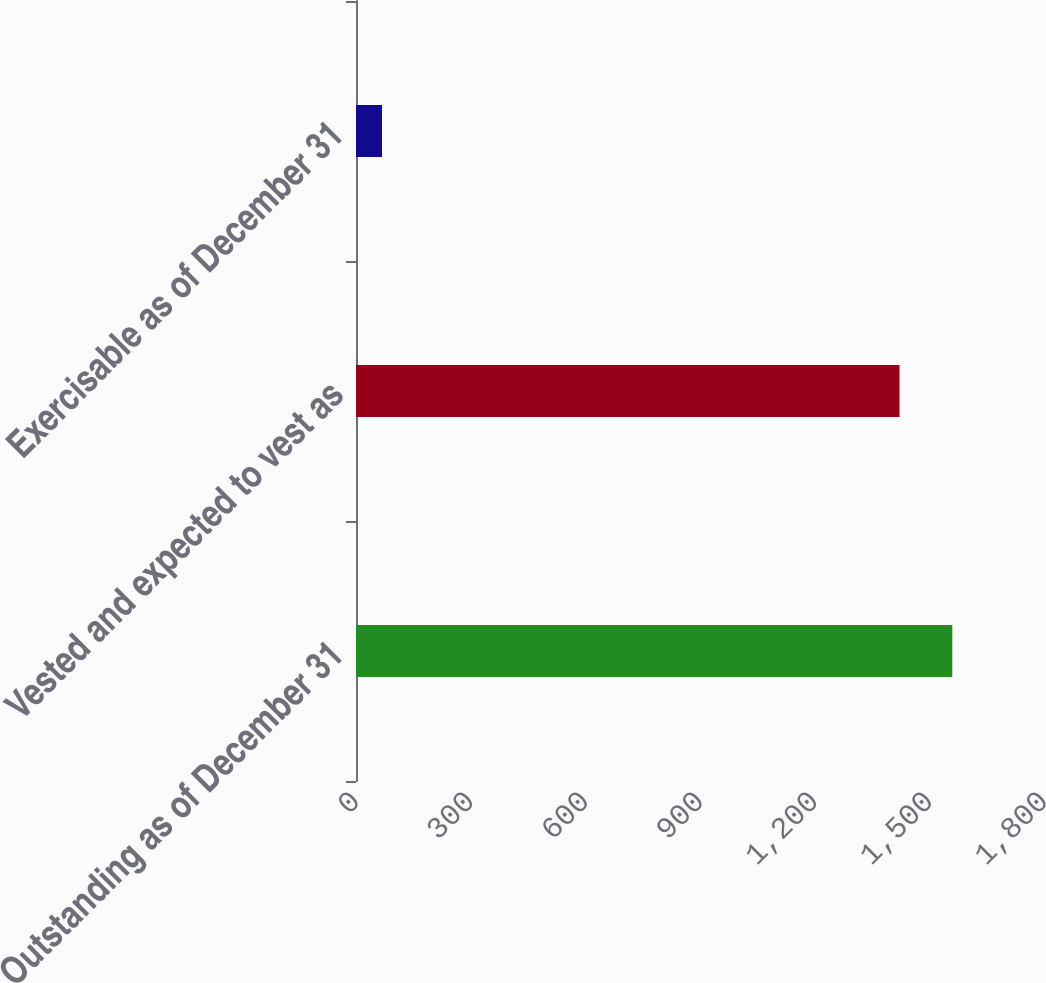Convert chart. <chart><loc_0><loc_0><loc_500><loc_500><bar_chart><fcel>Outstanding as of December 31<fcel>Vested and expected to vest as<fcel>Exercisable as of December 31<nl><fcel>1560.1<fcel>1422<fcel>68<nl></chart> 